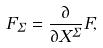<formula> <loc_0><loc_0><loc_500><loc_500>F _ { \Sigma } = \frac { \partial } { \partial X ^ { \Sigma } } F ,</formula> 